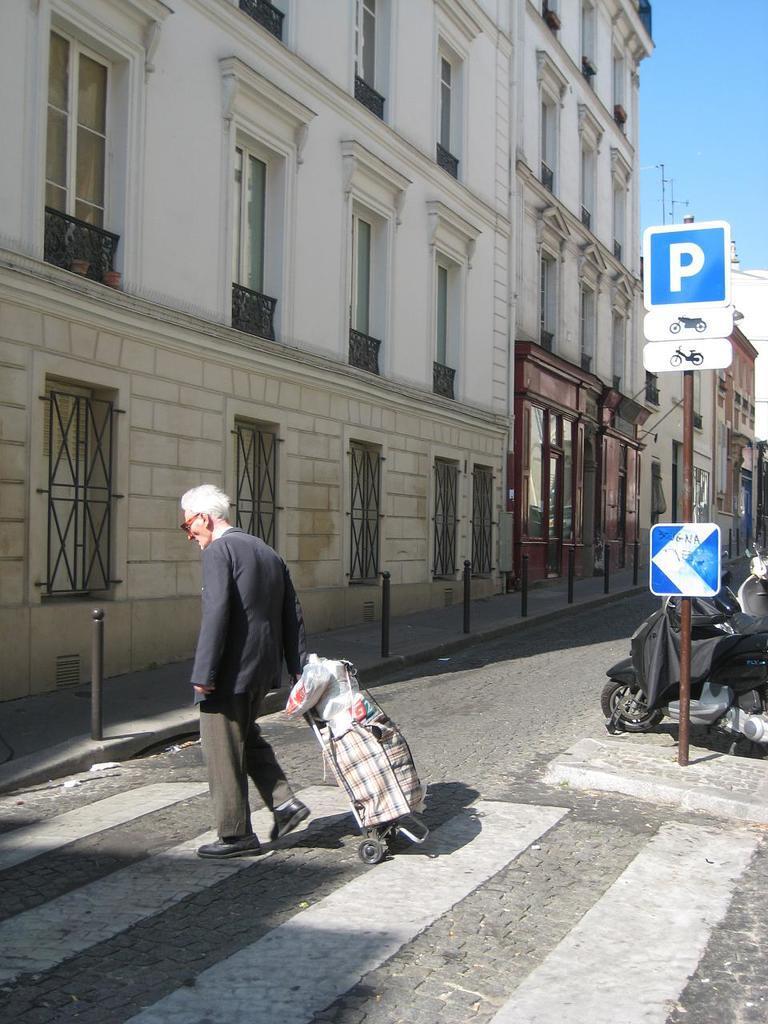Could you give a brief overview of what you see in this image? In the center of the image we can see one person is walking on the road and he is wearing glasses. And we can see he is holding some objects. In the background, we can see the sky, buildings, windows, fences, vehicles, poles, sign boards and a few other objects. 